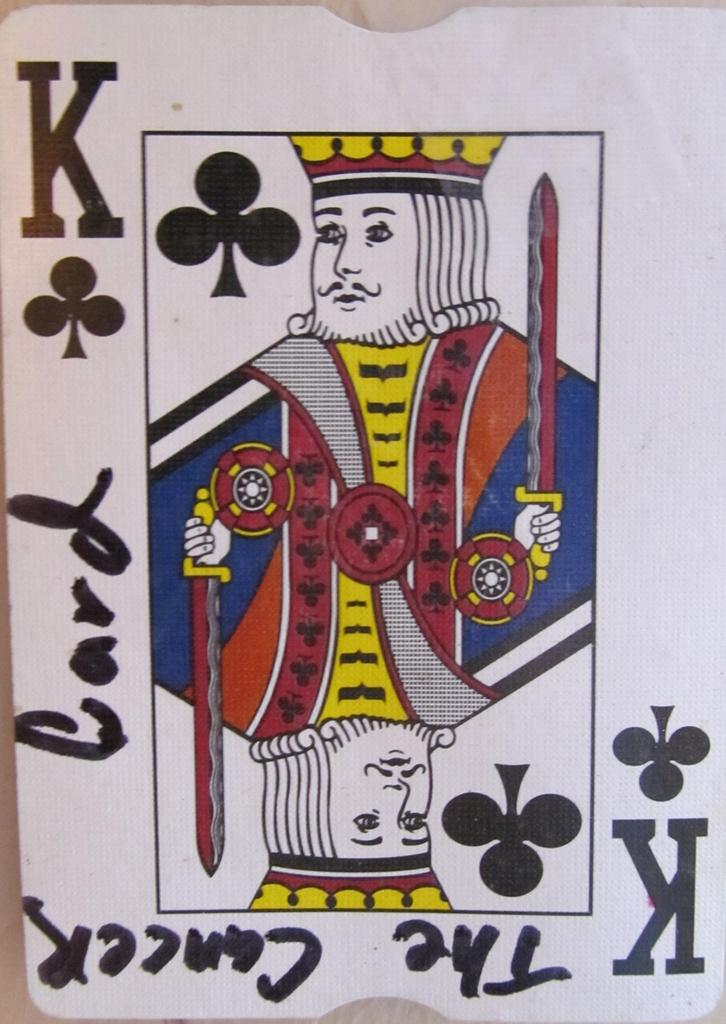<image>
Present a compact description of the photo's key features. The king of clubs from a deck of playing cards has the phrase the cancer card written on the white, outside border. 